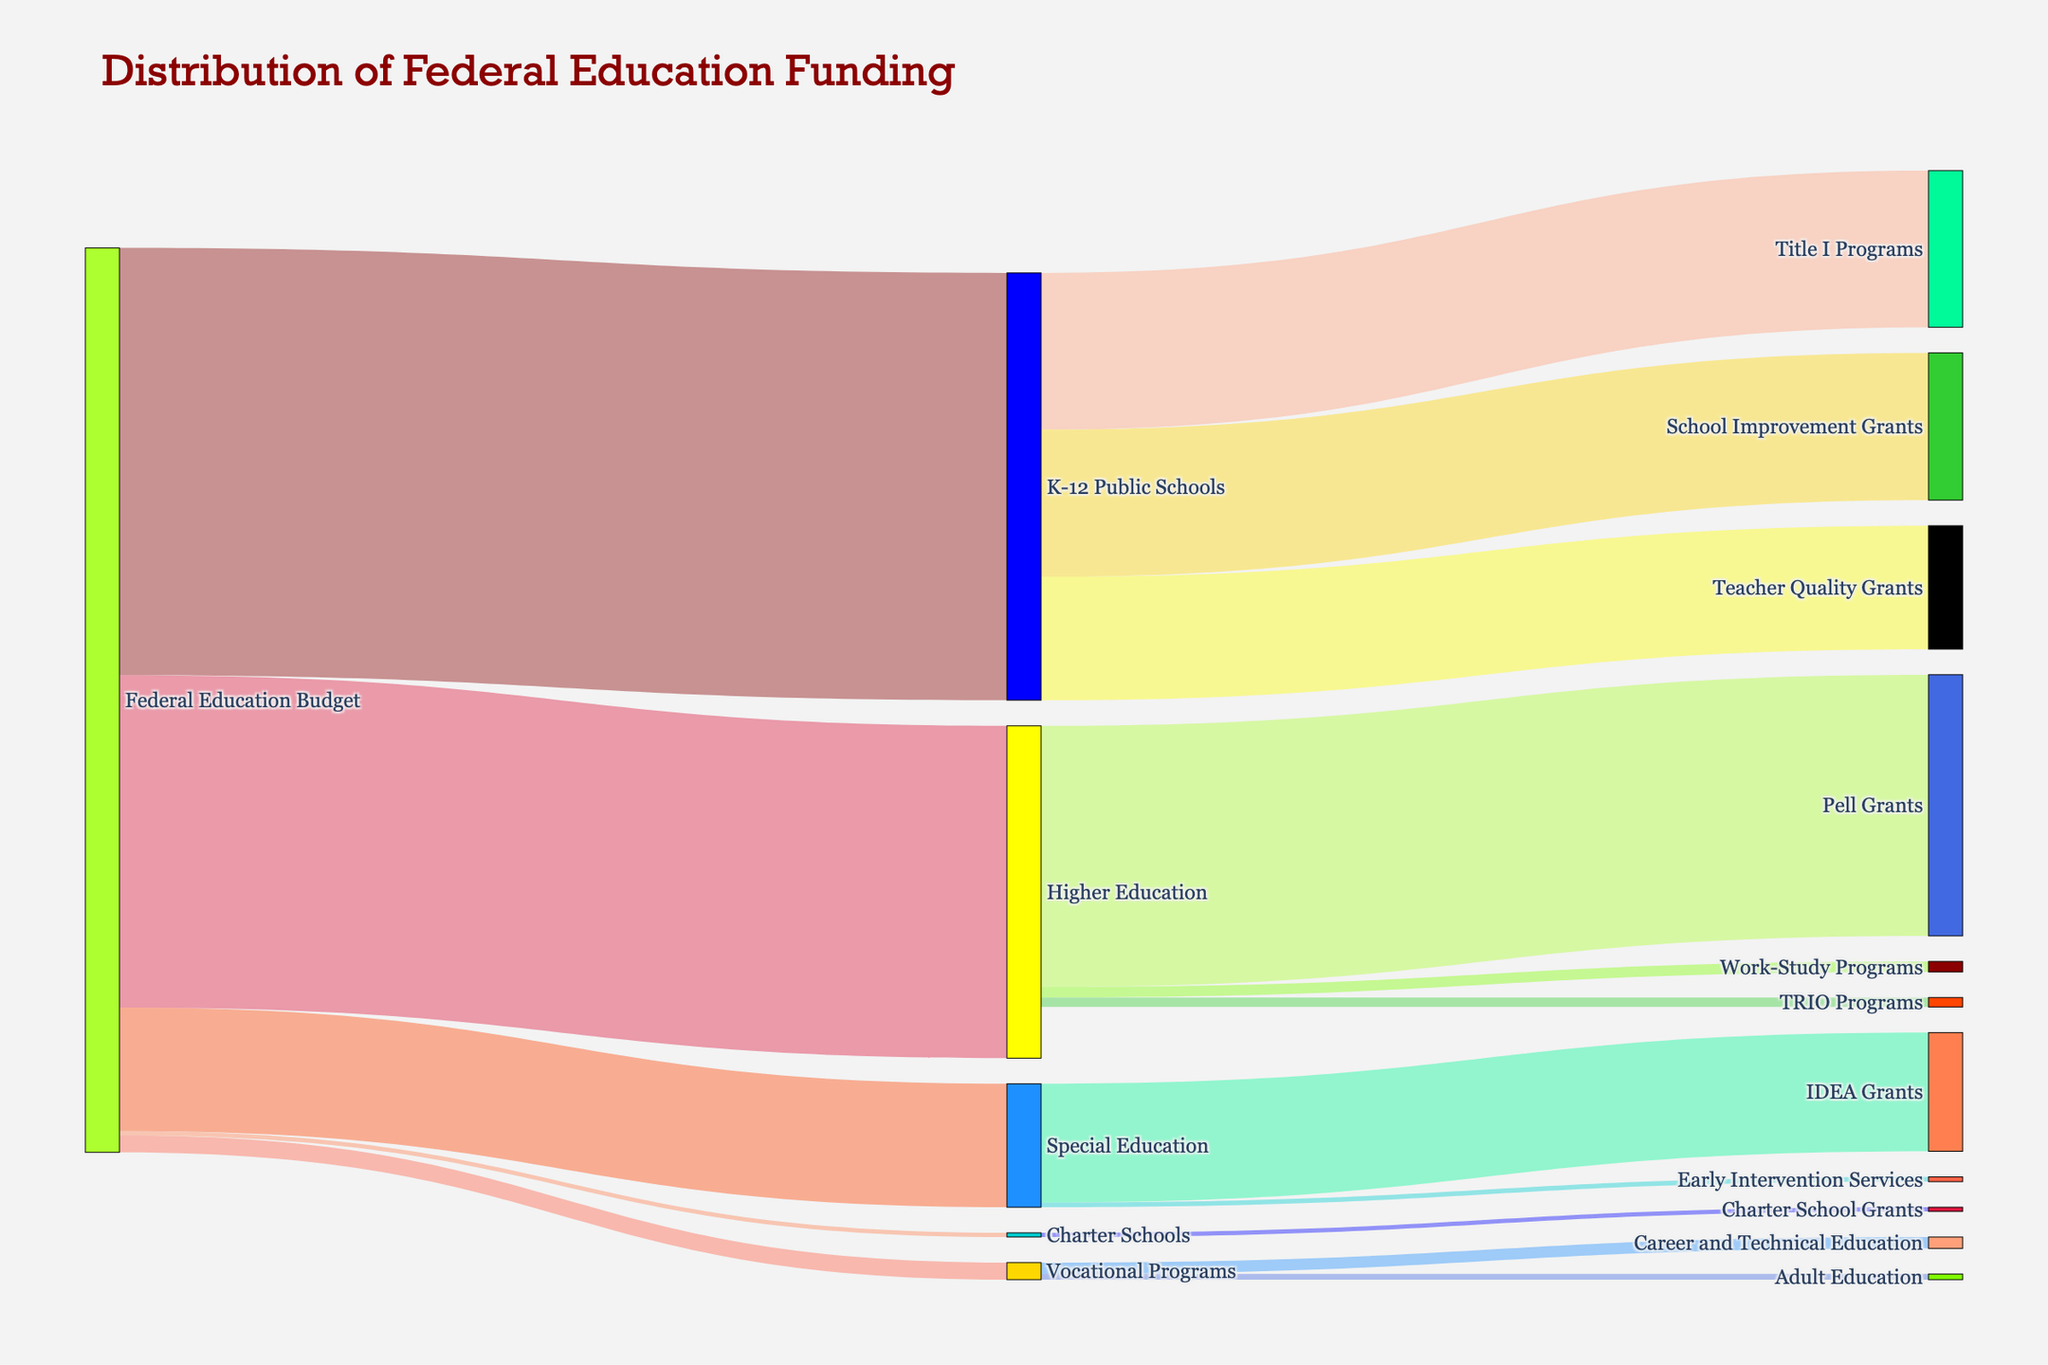what is the total federal education budget? The total federal education budget is the sum of all the education funds allocated to different types of schools and programs. By adding the values provided, we get: $45,000,000,000 (K-12 Public Schools) + $35,000,000,000 (Higher Education) + $13,000,000,000 (Special Education) + $1,800,000,000 (Vocational Programs) + $440,000,000 (Charter Schools) which equals $95,240,000,000 in total.
Answer: 95,240,000,000 which program, within K-12 Public Schools, receives the highest funding? Reviewing the K-12 Public Schools' funding distribution, Title I Programs receive $16,500,000,000, School Improvement Grants get $15,500,000,000, and Teacher Quality Grants are allocated $13,000,000,000. Therefore, Title I Programs receive the highest funding.
Answer: Title I Programs what is the total amount allocated to Higher Education? The total amount allocated within Higher Education includes: $27,500,000,000 (Pell Grants) + $1,100,000,000 (Work-Study Programs) + $1,000,000,000 (TRIO Programs), which sums up to $29,600,000,000.
Answer: 29,600,000,000 how much funding is given to the IDEA Grants? From the Special Education, the amount allocated specifically to IDEA Grants is $12,500,000,000 as indicated in the dataset.
Answer: 12,500,000,000 compare the funding for Career and Technical Education versus Adult Education within Vocational Programs. Which receives more? Career and Technical Education receives $1,200,000,000 while Adult Education gets $600,000,000. Therefore, Career and Technical Education receives significantly more funding.
Answer: Career and Technical Education what are the intermediate categories from the K-12 Public Schools allocation? The intermediate categories for K-12 Public Schools include Title I Programs, School Improvement Grants, and Teacher Quality Grants as per the figure's structure.
Answer: Title I Programs, School Improvement Grants, Teacher Quality Grants what is the difference in funding between Vocational Programs and Charter Schools? Vocational Programs receive $1,800,000,000 and Charter Schools receive $440,000,000. Subtracting these values accounts to a difference of $1,360,000,000.
Answer: 1,360,000,000 what percentage of the total federal education budget is allocated to Special Education? Special Education receives $13,000,000,000 out of the total $95,240,000,000 federal education budget. The percentage is calculated as ($13,000,000,000 / $95,240,000,000) * 100 which equals approximately 13.64%.
Answer: 13.64% based on the Sankey diagram, what are the main destinations of federal education funding? The main destinations of the federal education funding, as indicated by the diagram, are K-12 Public Schools, Higher Education, Special Education, Vocational Programs, and Charter Schools.
Answer: K-12 Public Schools, Higher Education, Special Education, Vocational Programs, Charter Schools 